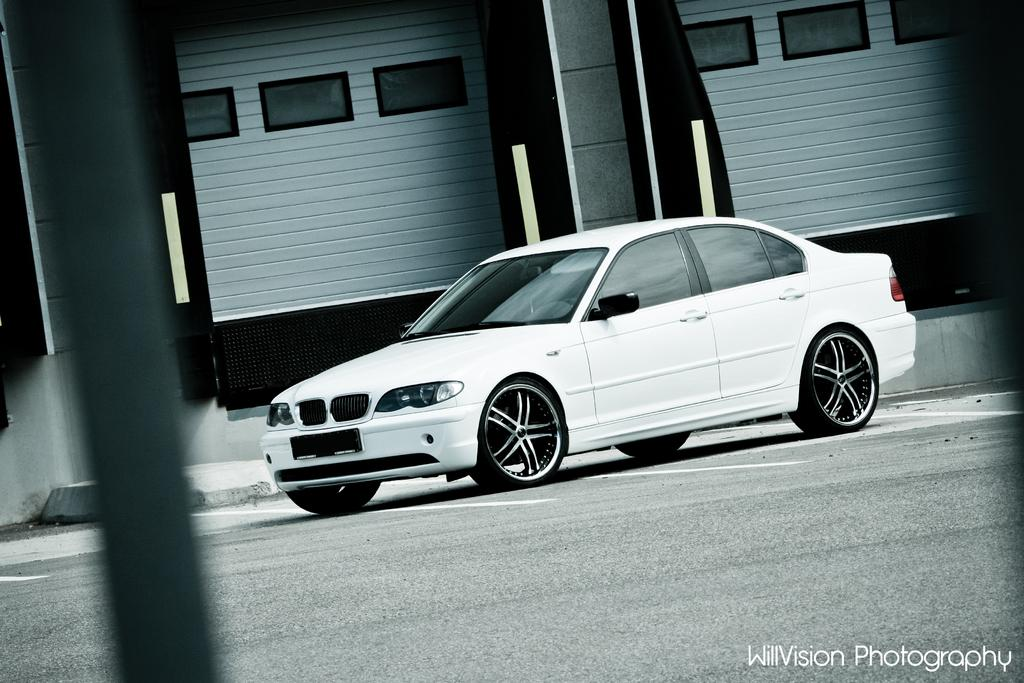What color is the car in the image? The car in the image is white. Where is the car located in the image? The car is on the road in the image. What can be seen in the background of the image? There is a wall visible in the background of the image. Is there any additional information or marking on the image? Yes, there is a watermark on the bottom right side of the image. What type of jeans is the car wearing in the image? Cars do not wear jeans; the question is not applicable to the image. 